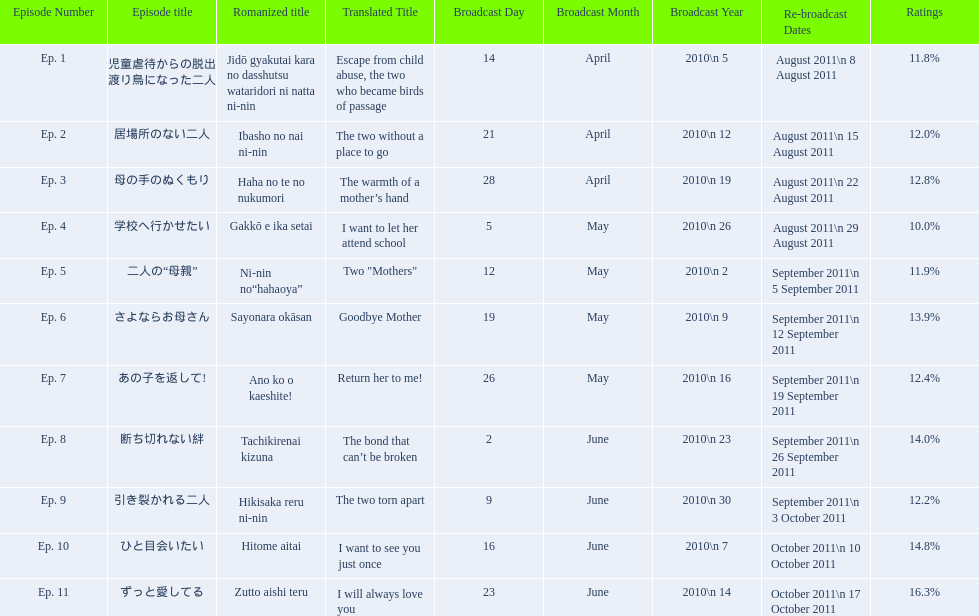What are all the episodes? Ep. 1, Ep. 2, Ep. 3, Ep. 4, Ep. 5, Ep. 6, Ep. 7, Ep. 8, Ep. 9, Ep. 10, Ep. 11. Of these, which ones have a rating of 14%? Ep. 8, Ep. 10. Of these, which one is not ep. 10? Ep. 8. 